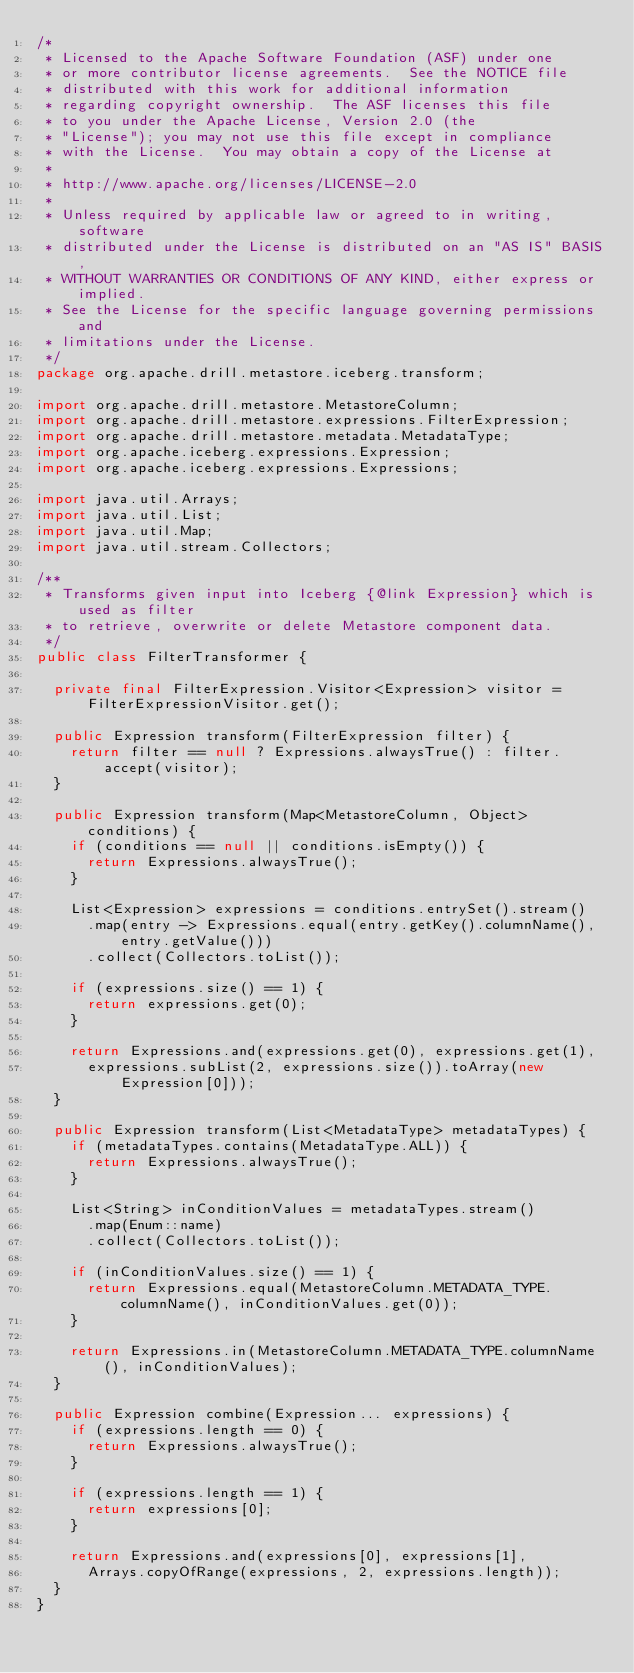<code> <loc_0><loc_0><loc_500><loc_500><_Java_>/*
 * Licensed to the Apache Software Foundation (ASF) under one
 * or more contributor license agreements.  See the NOTICE file
 * distributed with this work for additional information
 * regarding copyright ownership.  The ASF licenses this file
 * to you under the Apache License, Version 2.0 (the
 * "License"); you may not use this file except in compliance
 * with the License.  You may obtain a copy of the License at
 *
 * http://www.apache.org/licenses/LICENSE-2.0
 *
 * Unless required by applicable law or agreed to in writing, software
 * distributed under the License is distributed on an "AS IS" BASIS,
 * WITHOUT WARRANTIES OR CONDITIONS OF ANY KIND, either express or implied.
 * See the License for the specific language governing permissions and
 * limitations under the License.
 */
package org.apache.drill.metastore.iceberg.transform;

import org.apache.drill.metastore.MetastoreColumn;
import org.apache.drill.metastore.expressions.FilterExpression;
import org.apache.drill.metastore.metadata.MetadataType;
import org.apache.iceberg.expressions.Expression;
import org.apache.iceberg.expressions.Expressions;

import java.util.Arrays;
import java.util.List;
import java.util.Map;
import java.util.stream.Collectors;

/**
 * Transforms given input into Iceberg {@link Expression} which is used as filter
 * to retrieve, overwrite or delete Metastore component data.
 */
public class FilterTransformer {

  private final FilterExpression.Visitor<Expression> visitor = FilterExpressionVisitor.get();

  public Expression transform(FilterExpression filter) {
    return filter == null ? Expressions.alwaysTrue() : filter.accept(visitor);
  }

  public Expression transform(Map<MetastoreColumn, Object> conditions) {
    if (conditions == null || conditions.isEmpty()) {
      return Expressions.alwaysTrue();
    }

    List<Expression> expressions = conditions.entrySet().stream()
      .map(entry -> Expressions.equal(entry.getKey().columnName(), entry.getValue()))
      .collect(Collectors.toList());

    if (expressions.size() == 1) {
      return expressions.get(0);
    }

    return Expressions.and(expressions.get(0), expressions.get(1),
      expressions.subList(2, expressions.size()).toArray(new Expression[0]));
  }

  public Expression transform(List<MetadataType> metadataTypes) {
    if (metadataTypes.contains(MetadataType.ALL)) {
      return Expressions.alwaysTrue();
    }

    List<String> inConditionValues = metadataTypes.stream()
      .map(Enum::name)
      .collect(Collectors.toList());

    if (inConditionValues.size() == 1) {
      return Expressions.equal(MetastoreColumn.METADATA_TYPE.columnName(), inConditionValues.get(0));
    }

    return Expressions.in(MetastoreColumn.METADATA_TYPE.columnName(), inConditionValues);
  }

  public Expression combine(Expression... expressions) {
    if (expressions.length == 0) {
      return Expressions.alwaysTrue();
    }

    if (expressions.length == 1) {
      return expressions[0];
    }

    return Expressions.and(expressions[0], expressions[1],
      Arrays.copyOfRange(expressions, 2, expressions.length));
  }
}
</code> 